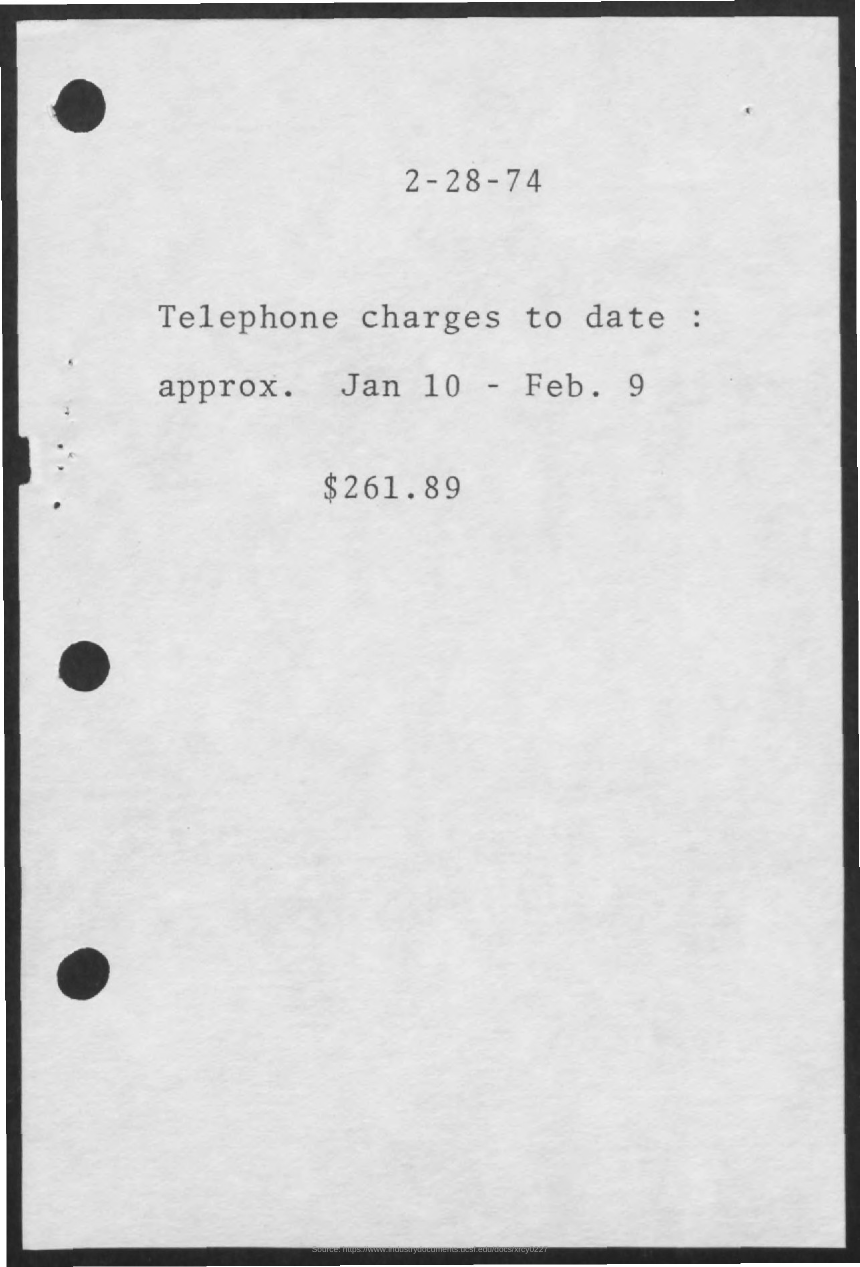What is total telephone charges? The total telephone charges as of the statement are $261.89, covering the period from approximately January 10 to February 9, as indicated by the document. 